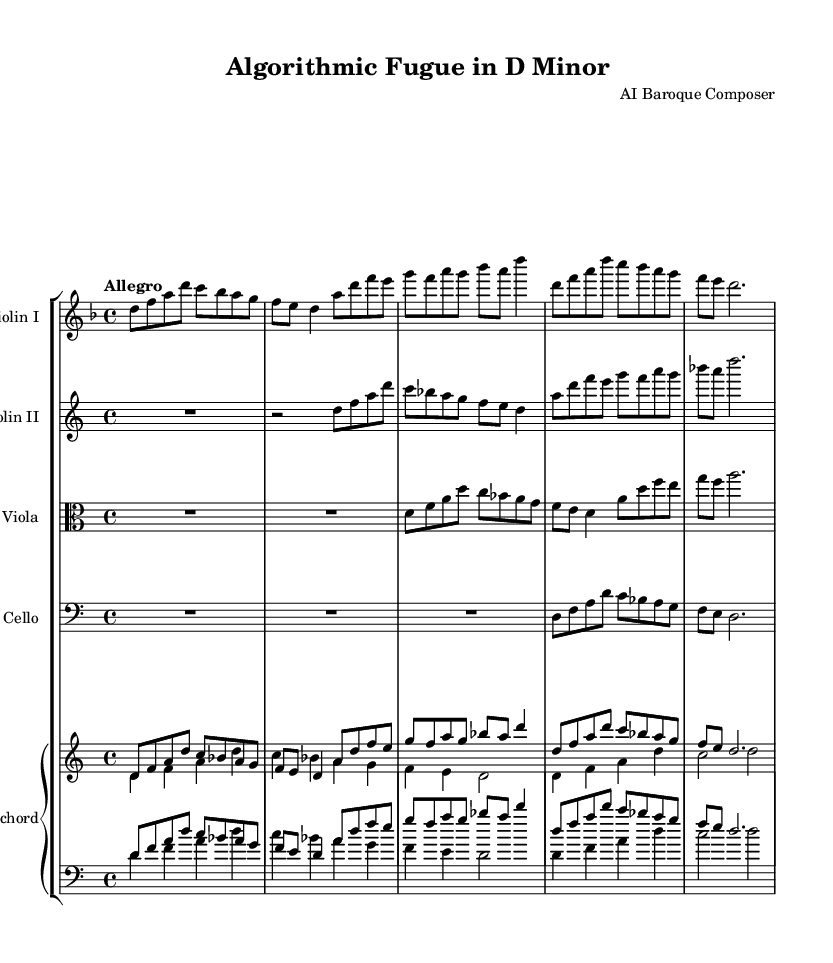What is the key signature of this music? The key signature is indicated at the beginning of the score. There are one flat (B) in the key signature, which means the piece is in D minor.
Answer: D minor What is the time signature of this piece? The time signature is found at the beginning of the score, represented by the fraction 4/4. This means there are four beats in each measure.
Answer: 4/4 What is the tempo marking of the piece? The tempo marking is indicated near the top of the score. It states "Allegro", which suggests a fast pace for the music.
Answer: Allegro How many distinct instruments are in the orchestration? By examining the score, we can see that there are four separate instruments: Violin I, Violin II, Viola, Cello, and a Harpsichord as a keyboard instrument. Counting these gives us five distinct parts or sections.
Answer: Five Which instrument plays the lowest range? The lowest range is played by the Cello, which is written in the bass clef. The notes played by the Cello are positioned lower than the other instruments in the score.
Answer: Cello How many measures are present in the Violin I part? Looking through the Violin I part, we can count seven measures in total. The number of bar lines indicates the separation of measures, showing distinct sections.
Answer: Seven 